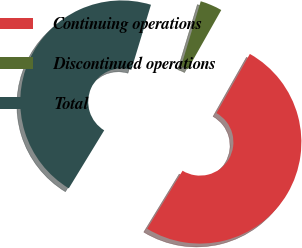<chart> <loc_0><loc_0><loc_500><loc_500><pie_chart><fcel>Continuing operations<fcel>Discontinued operations<fcel>Total<nl><fcel>50.54%<fcel>3.51%<fcel>45.95%<nl></chart> 